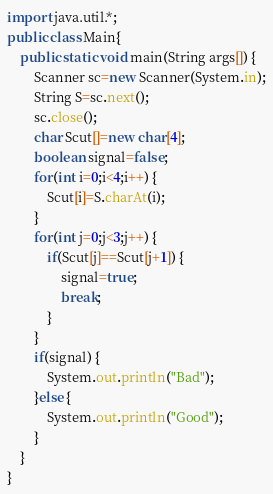Convert code to text. <code><loc_0><loc_0><loc_500><loc_500><_Java_>import java.util.*;
public class Main{
	public static void main(String args[]) {
		Scanner sc=new Scanner(System.in);
		String S=sc.next();
		sc.close();
		char Scut[]=new char[4];
		boolean signal=false;
		for(int i=0;i<4;i++) {
			Scut[i]=S.charAt(i);
		}
		for(int j=0;j<3;j++) {
			if(Scut[j]==Scut[j+1]) {
				signal=true;
				break;
			}
		}
		if(signal) {
			System.out.println("Bad");
		}else {
			System.out.println("Good");
		}
	}
}</code> 